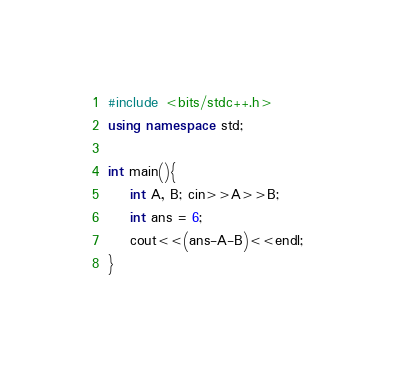<code> <loc_0><loc_0><loc_500><loc_500><_C++_>#include <bits/stdc++.h>
using namespace std;

int main(){
    int A, B; cin>>A>>B;
    int ans = 6;
    cout<<(ans-A-B)<<endl;
}</code> 